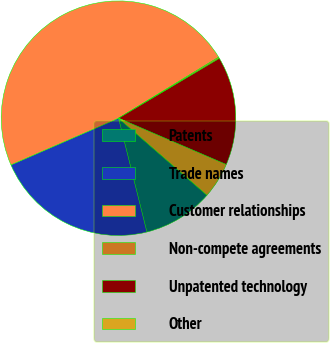<chart> <loc_0><loc_0><loc_500><loc_500><pie_chart><fcel>Patents<fcel>Trade names<fcel>Customer relationships<fcel>Non-compete agreements<fcel>Unpatented technology<fcel>Other<nl><fcel>9.71%<fcel>22.37%<fcel>47.81%<fcel>0.18%<fcel>14.99%<fcel>4.94%<nl></chart> 